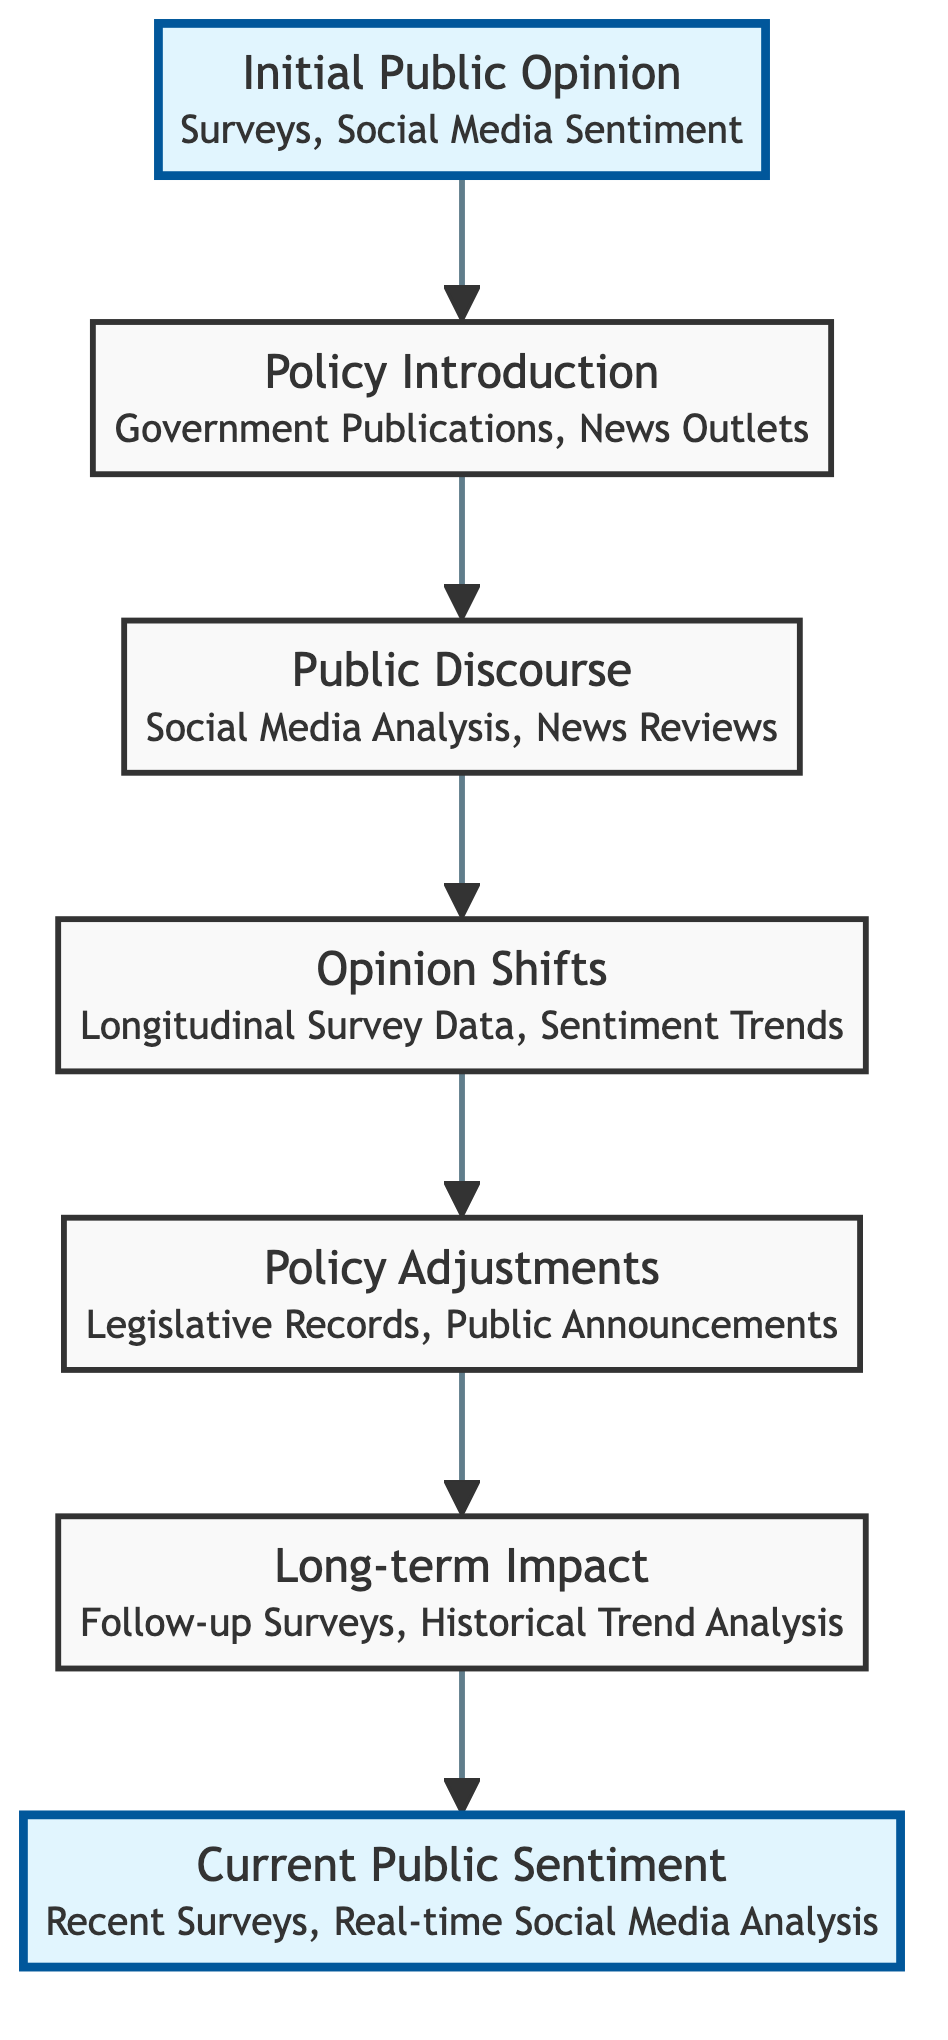What is the first node in the flowchart? The first node is labeled "Initial Public Opinion," which represents the baseline sentiment analysis of the public's initial stance on the social policy.
Answer: Initial Public Opinion How many nodes are in the diagram? There are a total of seven nodes that depict various stages of public opinion evolution in response to social policies.
Answer: 7 What connects "Public Discourse" to "Opinion Shifts"? "Public Discourse" is directly connected to "Opinion Shifts" through a flow line, indicating the progression from public reaction to measurable changes in opinion.
Answer: One arrow What is the last node in the flowchart? The last node is labeled "Current Public Sentiment," representing present-day public opinion on the policy after all adjustments.
Answer: Current Public Sentiment What data sources are related to "Policy Introduction"? The node "Policy Introduction" is associated with data sources including "Government Publications" and "News Outlets."
Answer: Government Publications, News Outlets What is the relationship between "Opinion Shifts" and "Policy Adjustments"? "Opinion Shifts" precede "Policy Adjustments," indicating that shifts in public opinion can lead to modifications in policy in response to public feedback.
Answer: Sequential progression Which two nodes are highlighted in the diagram? The nodes highlighted in the diagram are "Initial Public Opinion" and "Current Public Sentiment," emphasizing the starting and ending points of the flowchart.
Answer: Initial Public Opinion, Current Public Sentiment What is the main purpose of the flowchart? The main purpose is to depict the evolution of public opinion over time in response to various social policies, showing how opinions change as a result of different factors.
Answer: Evolution of public opinion What kind of analysis is conducted for "Long-term Impact"? The analysis for "Long-term Impact" involves "Follow-up Surveys" and "Historical Trend Analysis," which help assess the lasting effects of the policy.
Answer: Follow-up Surveys, Historical Trend Analysis 